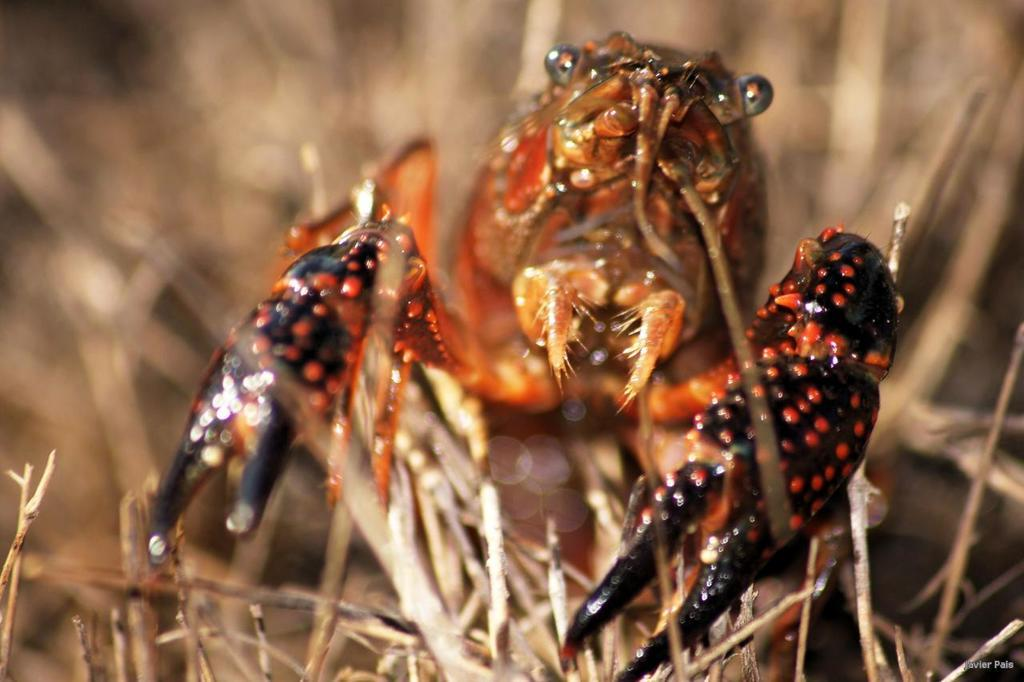What type of animal is in the image? There is a crab in the image. What type of vegetation is present in the image? There is grass in the image. Can you describe the background of the image? The background of the image is blurred. What type of history can be seen in the image? There is no history present in the image; it features a crab and grass with a blurred background. 